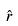Convert formula to latex. <formula><loc_0><loc_0><loc_500><loc_500>\hat { r }</formula> 